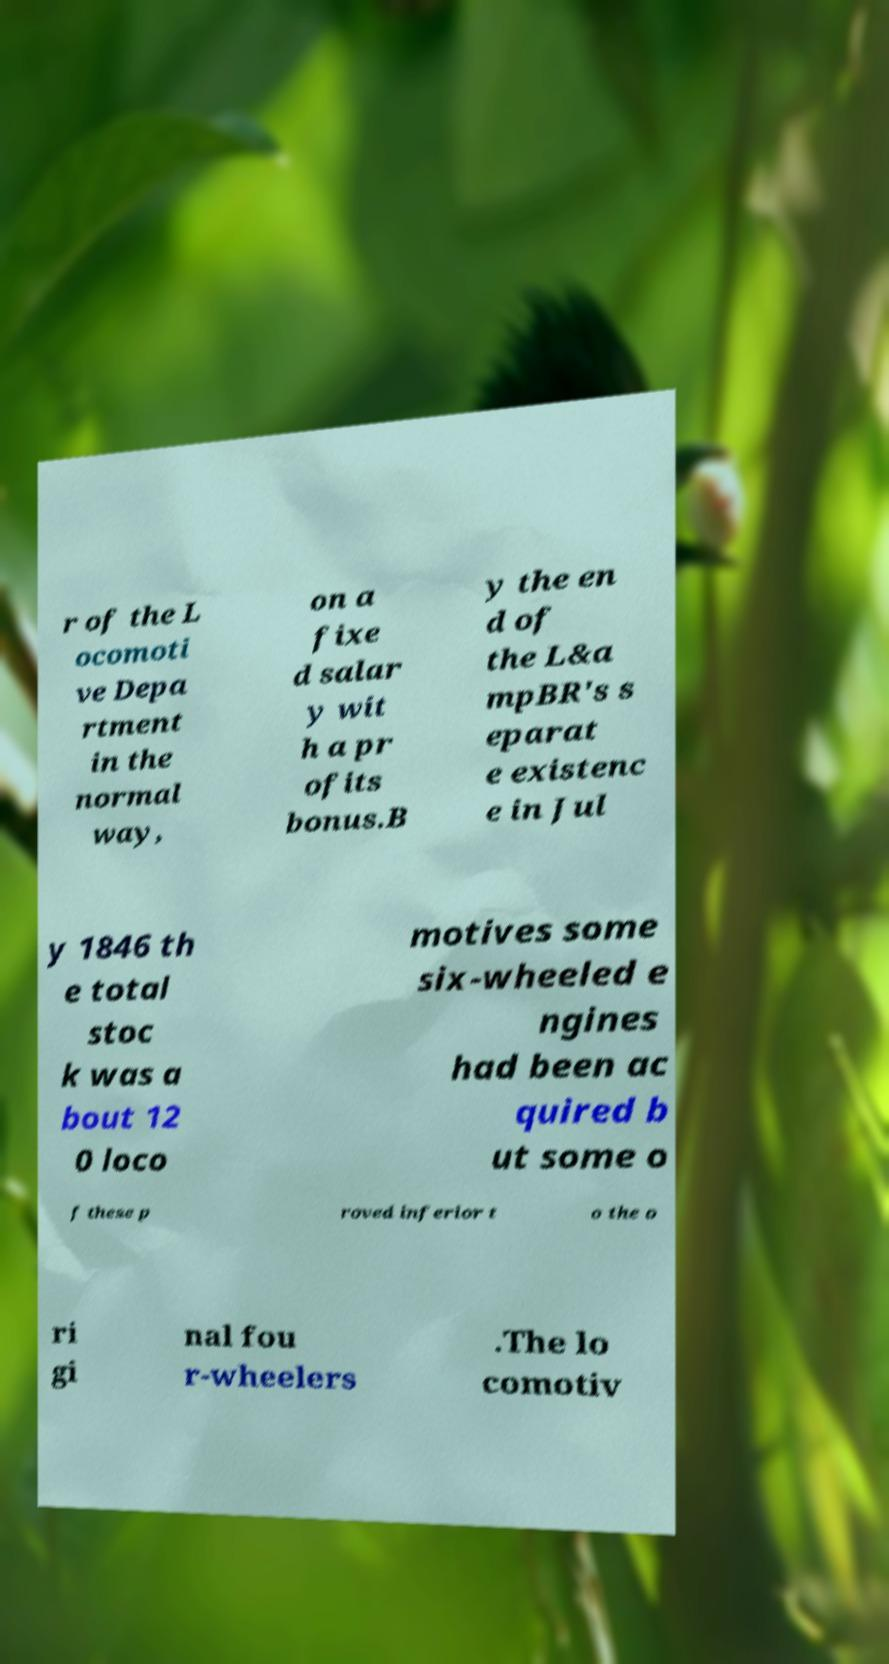What messages or text are displayed in this image? I need them in a readable, typed format. r of the L ocomoti ve Depa rtment in the normal way, on a fixe d salar y wit h a pr ofits bonus.B y the en d of the L&a mpBR's s eparat e existenc e in Jul y 1846 th e total stoc k was a bout 12 0 loco motives some six-wheeled e ngines had been ac quired b ut some o f these p roved inferior t o the o ri gi nal fou r-wheelers .The lo comotiv 